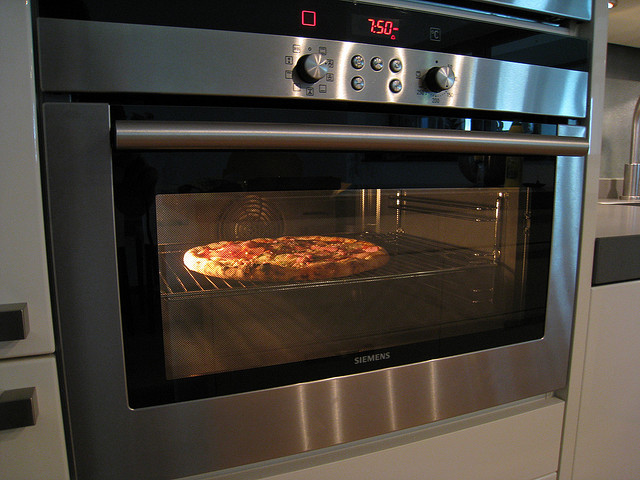Please transcribe the text in this image. SIEMENS 50 7 c 